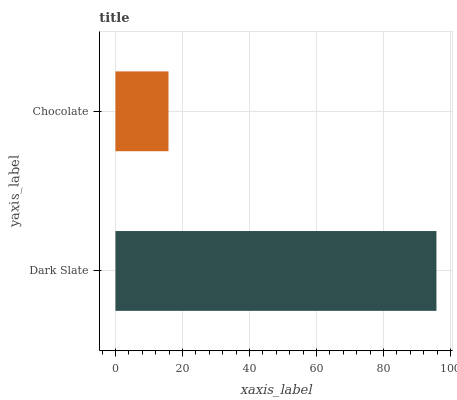Is Chocolate the minimum?
Answer yes or no. Yes. Is Dark Slate the maximum?
Answer yes or no. Yes. Is Chocolate the maximum?
Answer yes or no. No. Is Dark Slate greater than Chocolate?
Answer yes or no. Yes. Is Chocolate less than Dark Slate?
Answer yes or no. Yes. Is Chocolate greater than Dark Slate?
Answer yes or no. No. Is Dark Slate less than Chocolate?
Answer yes or no. No. Is Dark Slate the high median?
Answer yes or no. Yes. Is Chocolate the low median?
Answer yes or no. Yes. Is Chocolate the high median?
Answer yes or no. No. Is Dark Slate the low median?
Answer yes or no. No. 